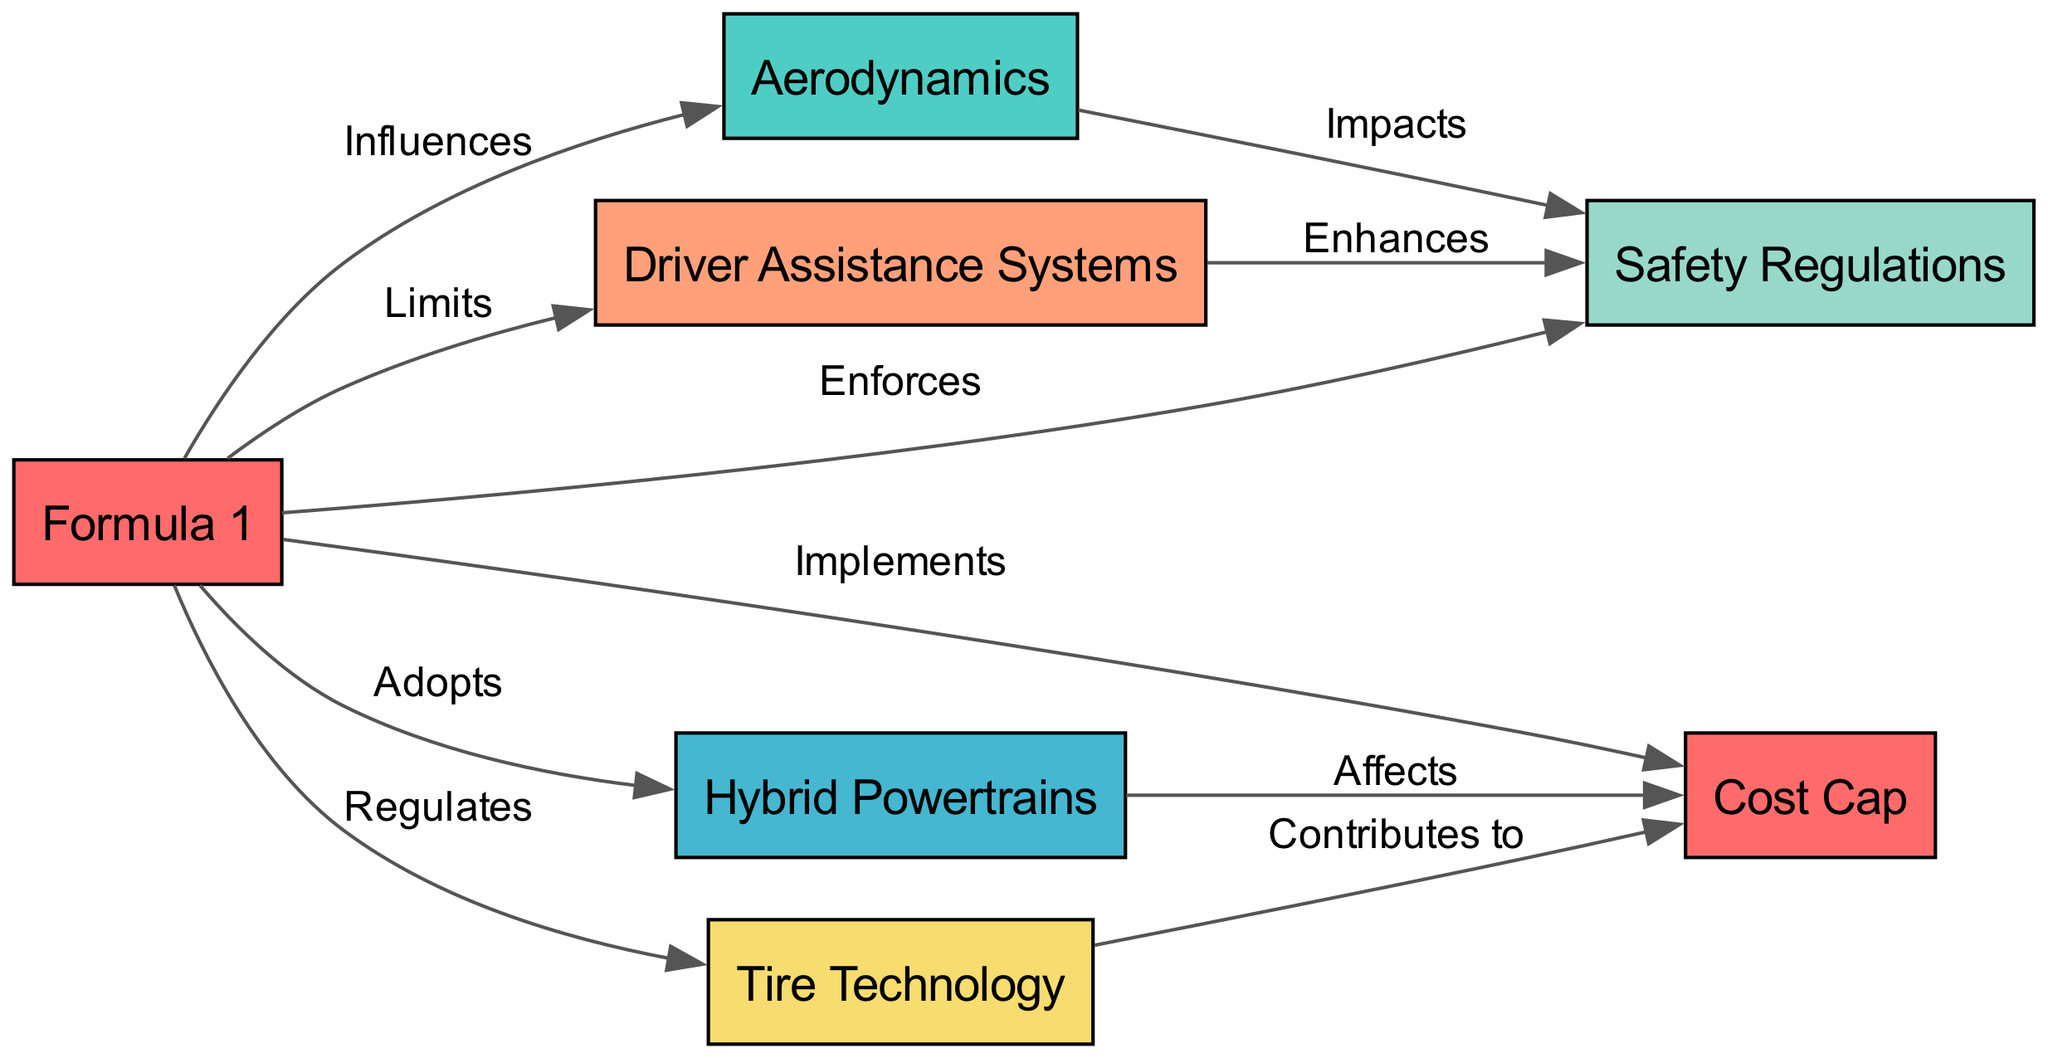What is the total number of nodes in the diagram? The diagram contains several nodes that represent various aspects of Formula 1 racing. By counting each node listed in the data, I confirm there are a total of seven nodes.
Answer: 7 Which node influences aerodynamics? The directed edge labeled "Influences" indicates that Formula 1, as the main node, has a direct influence on the node representing aerodynamics.
Answer: Formula 1 How many relationships are present between the nodes? By counting the edges defined in the data, I find that there are a total of ten different relationships connecting the various nodes in the diagram.
Answer: 10 What does hybrid powertrains affect in the diagram? The edge labeled "Affects" shows that hybrid powertrains affect the cost cap, indicating a direct impact on that node.
Answer: Cost Cap Which node is regulated by Formula 1? According to the edge labeled "Regulates," Formula 1 has a regulatory influence over tire technology. This indicates what Formula 1 oversees or maintains standards for.
Answer: Tire Technology How does driver assistance systems enhance safety regulations? The "Enhances" edge indicates that driver assistance systems have a positive effect on safety regulations, suggesting an improvement in safety due to advancements in driver assistance technology.
Answer: Safety Regulations Which technological advancement does the cost cap impact? The diagram shows an edge labeled "Affects" between hybrid powertrains and the cost cap. This indicates that the implementation or discussion of a cost cap has implications for hybrid powertrains.
Answer: Hybrid Powertrains Which two nodes are impacted by aerodynamics? Looking at the edges connected to aerodynamics, I see it has a direct impact on safety regulations. This requires looking at the "Impacts" edge to determine the connected node.
Answer: Safety Regulations What does tire technology contribute to? The data indicates that tire technology has an edge labeled "Contributes to," which points to the cost cap. This illustrates the relationship between advancements in tire technology and constraints placed by the cost cap.
Answer: Cost Cap 